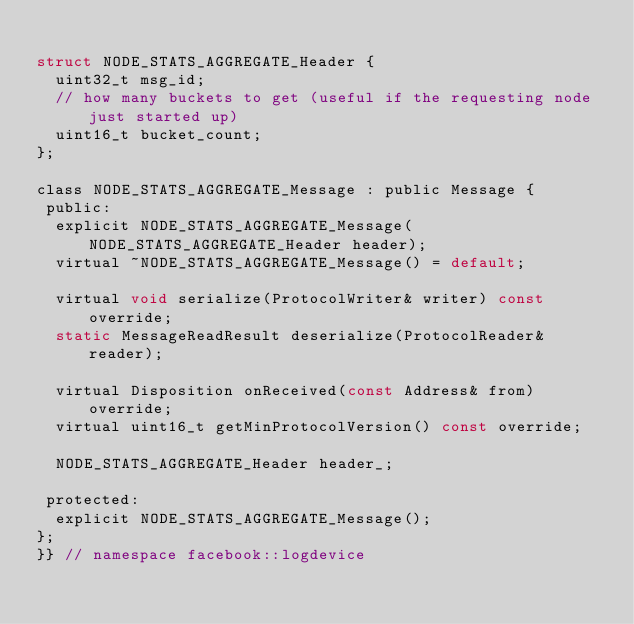Convert code to text. <code><loc_0><loc_0><loc_500><loc_500><_C_>
struct NODE_STATS_AGGREGATE_Header {
  uint32_t msg_id;
  // how many buckets to get (useful if the requesting node just started up)
  uint16_t bucket_count;
};

class NODE_STATS_AGGREGATE_Message : public Message {
 public:
  explicit NODE_STATS_AGGREGATE_Message(NODE_STATS_AGGREGATE_Header header);
  virtual ~NODE_STATS_AGGREGATE_Message() = default;

  virtual void serialize(ProtocolWriter& writer) const override;
  static MessageReadResult deserialize(ProtocolReader& reader);

  virtual Disposition onReceived(const Address& from) override;
  virtual uint16_t getMinProtocolVersion() const override;

  NODE_STATS_AGGREGATE_Header header_;

 protected:
  explicit NODE_STATS_AGGREGATE_Message();
};
}} // namespace facebook::logdevice
</code> 